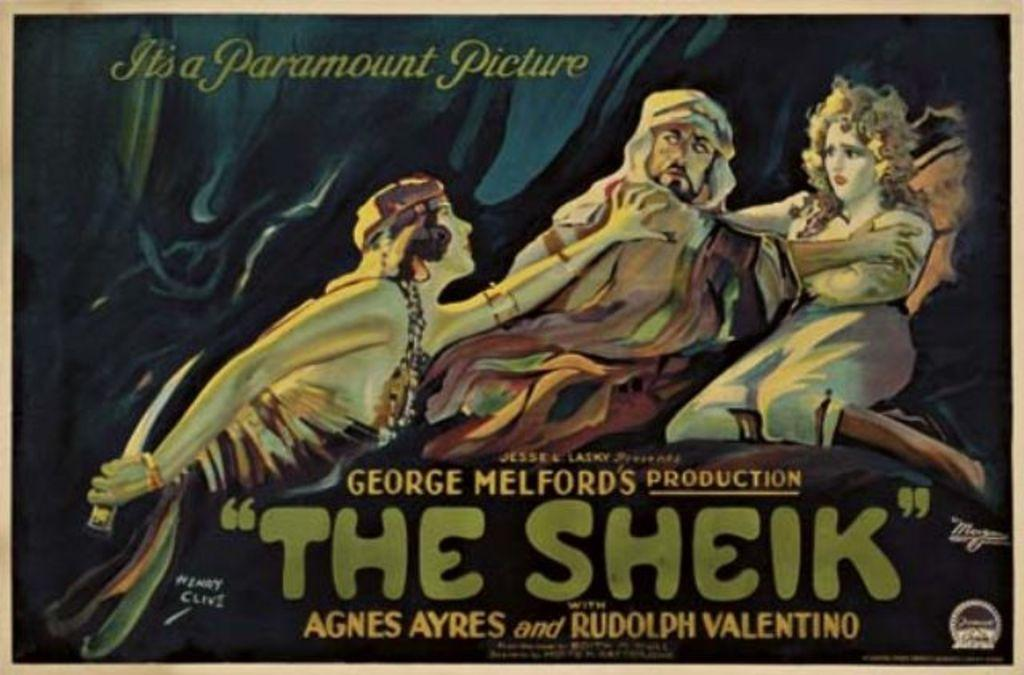<image>
Create a compact narrative representing the image presented. It's a paramount picture of the Sheik a george melford's production 